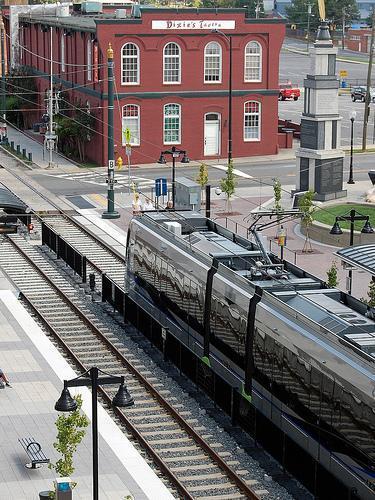How many trains are shown?
Give a very brief answer. 1. 